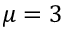Convert formula to latex. <formula><loc_0><loc_0><loc_500><loc_500>\mu = 3</formula> 